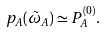Convert formula to latex. <formula><loc_0><loc_0><loc_500><loc_500>p _ { A } ( \tilde { \omega } _ { A } ) \simeq P _ { A } ^ { ( 0 ) } .</formula> 